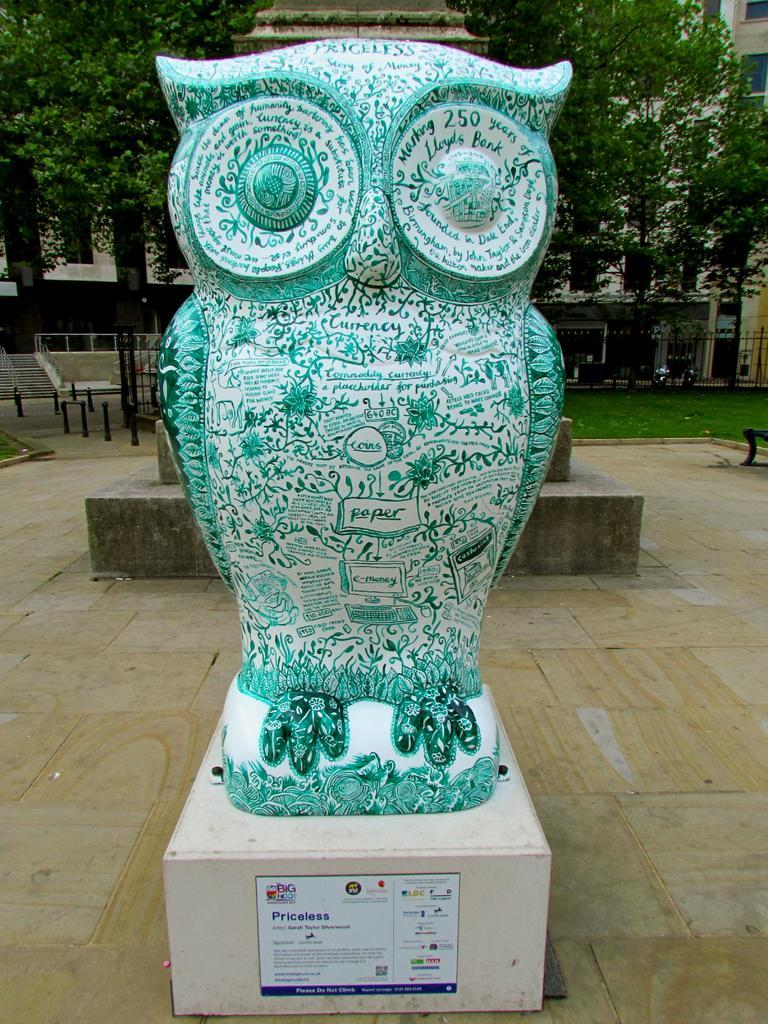What is the main subject of the image? There is a statue of an owl in the image. What is the statue placed on? There is a platform in the image. What can be seen in the background of the image? There are trees, buildings, windows, rods, fencing, poles, and stairs visible in the background. What type of vegetation is present in the background? There is grass in the background of the image. What type of glass is being used to create the farm in the image? There is no farm present in the image, and therefore no glass being used to create it. 